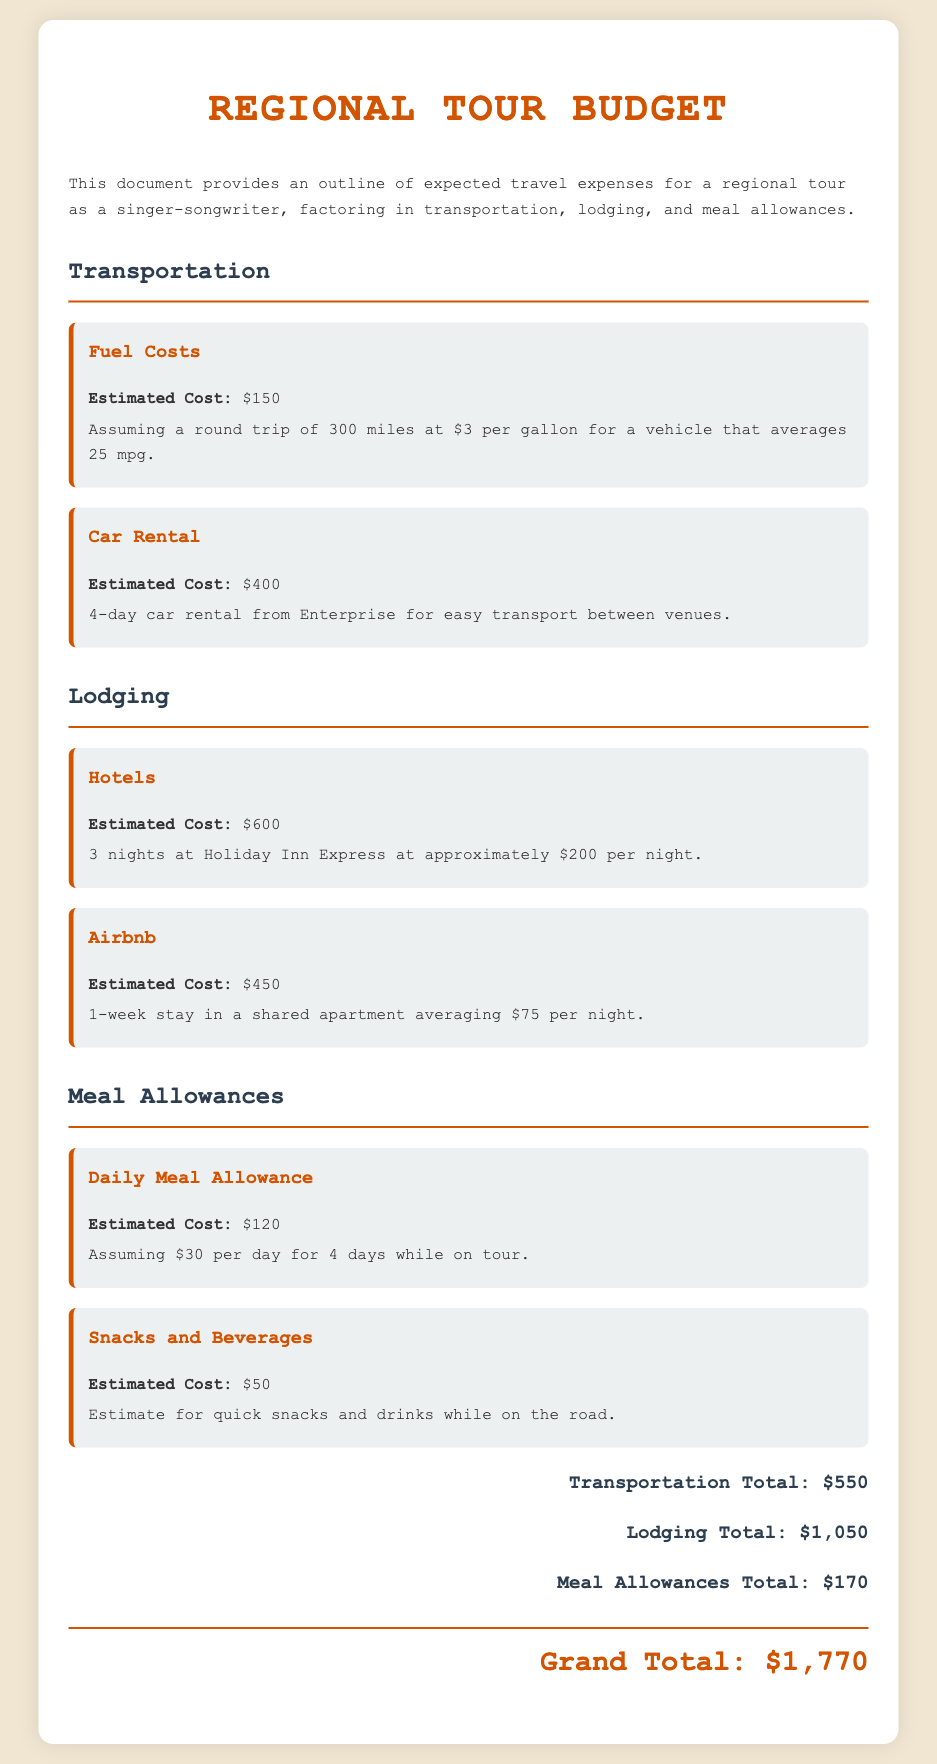What is the estimated cost for fuel? The estimated cost for fuel is stated as $150 in the transportation section of the document.
Answer: $150 How many nights are planned for the hotel stay? The document mentions a stay of 3 nights at Holiday Inn Express in the lodging section.
Answer: 3 nights What is the total estimated cost for lodging? The total estimated cost for lodging, including hotels and Airbnb, is calculated as $600 + $450 = $1050 in the document.
Answer: $1050 How much is the daily meal allowance? The daily meal allowance is specified as $30 per day for 4 days; this information can be found in the meal allowances section.
Answer: $30 What is the grand total of all expenses? The grand total is summarized at the end of the document, which adds up all transportation, lodging, and meal allowances costs.
Answer: $1770 How much is allocated for snacks and beverages? The budget for snacks and beverages is specifically noted as $50 in the meal allowances section.
Answer: $50 What is the estimation for the car rental cost? The document indicates that the estimated cost for car rental is $400 for a 4-day rental period.
Answer: $400 What type of lodging has a higher estimated cost, hotels or Airbnb? The comparison shows that hotels have an estimated cost of $600, while Airbnb is $450, indicating hotels are more expensive.
Answer: Hotels How many days is the tour assumed to last for meal allowance calculations? The document calculates the meal allowance for 4 days while on tour, which is explicitly stated in that section.
Answer: 4 days 